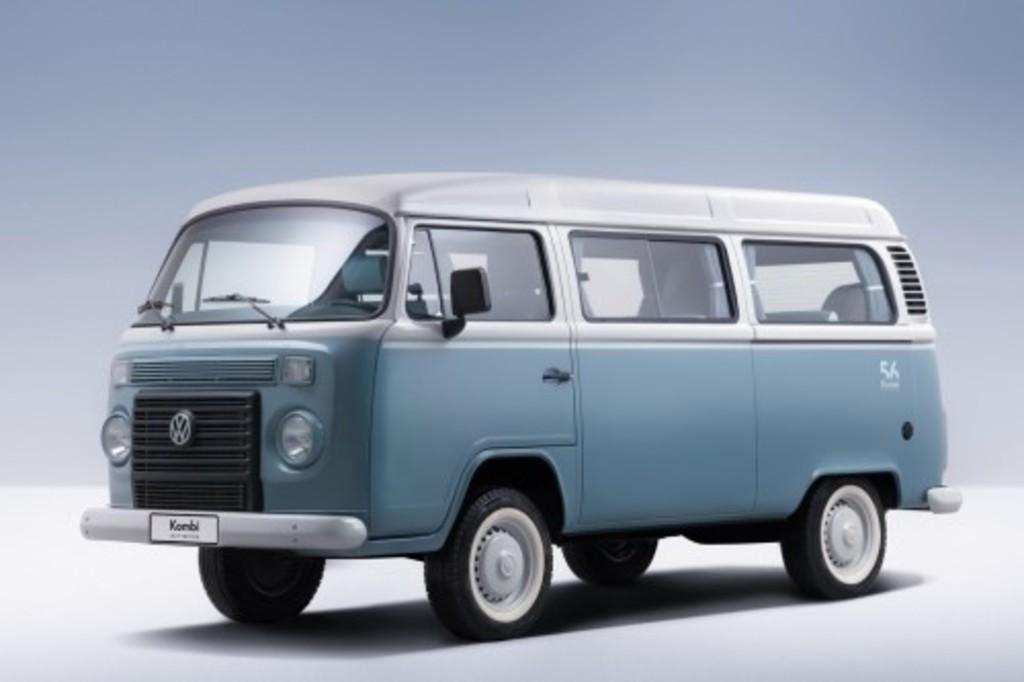<image>
Share a concise interpretation of the image provided. The new VW van is the 56th addition. 